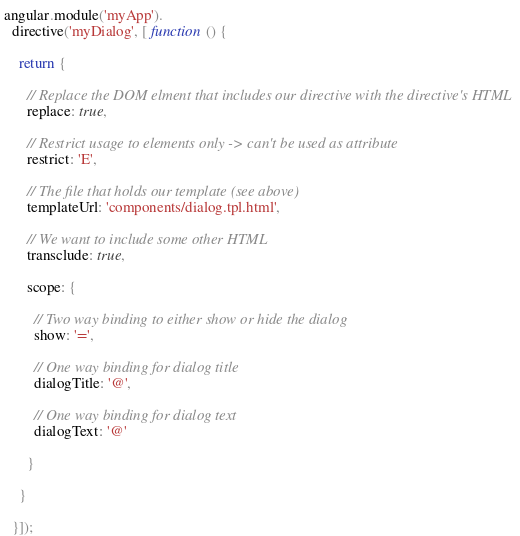Convert code to text. <code><loc_0><loc_0><loc_500><loc_500><_JavaScript_>angular.module('myApp').
  directive('myDialog', [ function () {

    return {

      // Replace the DOM elment that includes our directive with the directive's HTML
      replace: true,

      // Restrict usage to elements only -> can't be used as attribute
      restrict: 'E',

      // The file that holds our template (see above)
      templateUrl: 'components/dialog.tpl.html',

      // We want to include some other HTML
      transclude: true,

      scope: {

        // Two way binding to either show or hide the dialog
        show: '=',

        // One way binding for dialog title
        dialogTitle: '@',

        // One way binding for dialog text
        dialogText: '@'

      }

    }

  }]);
</code> 